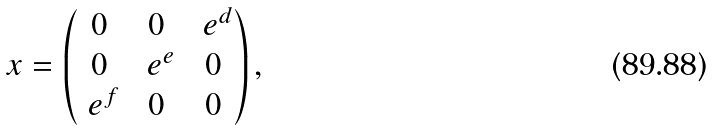<formula> <loc_0><loc_0><loc_500><loc_500>x = \begin{pmatrix} 0 & 0 & \ e ^ { d } \\ 0 & \ e ^ { e } & 0 \\ \ e ^ { f } & 0 & 0 \end{pmatrix} ,</formula> 